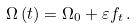<formula> <loc_0><loc_0><loc_500><loc_500>\Omega \left ( t \right ) = \Omega _ { 0 } + \varepsilon f _ { t } \, .</formula> 